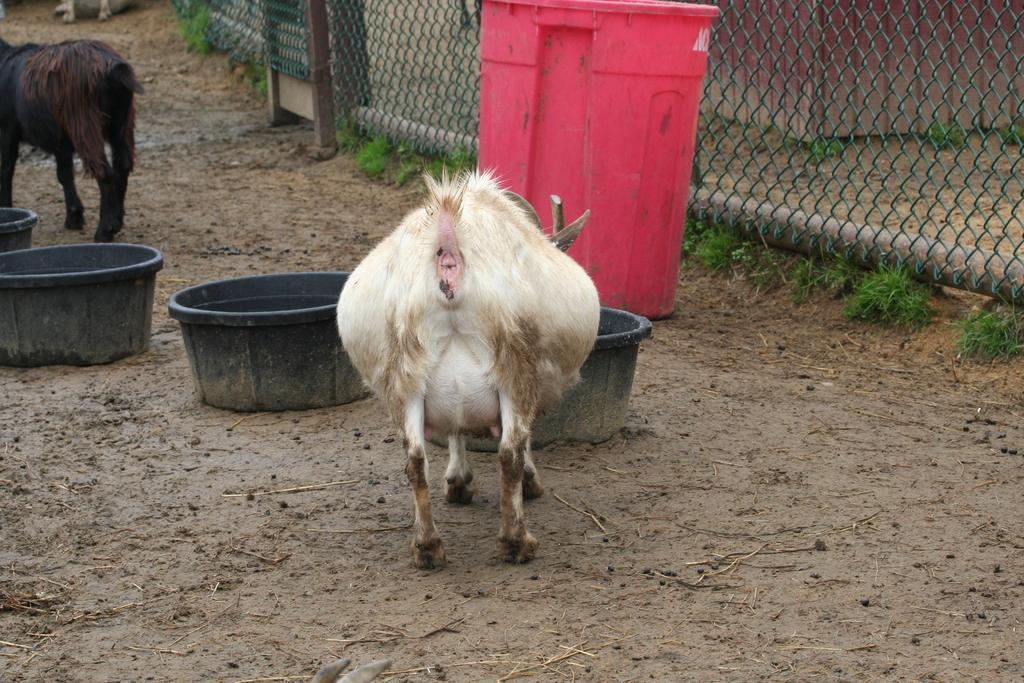Can you describe this image briefly? In this image there are animals, containers, bin, mesh, grass and objects.   